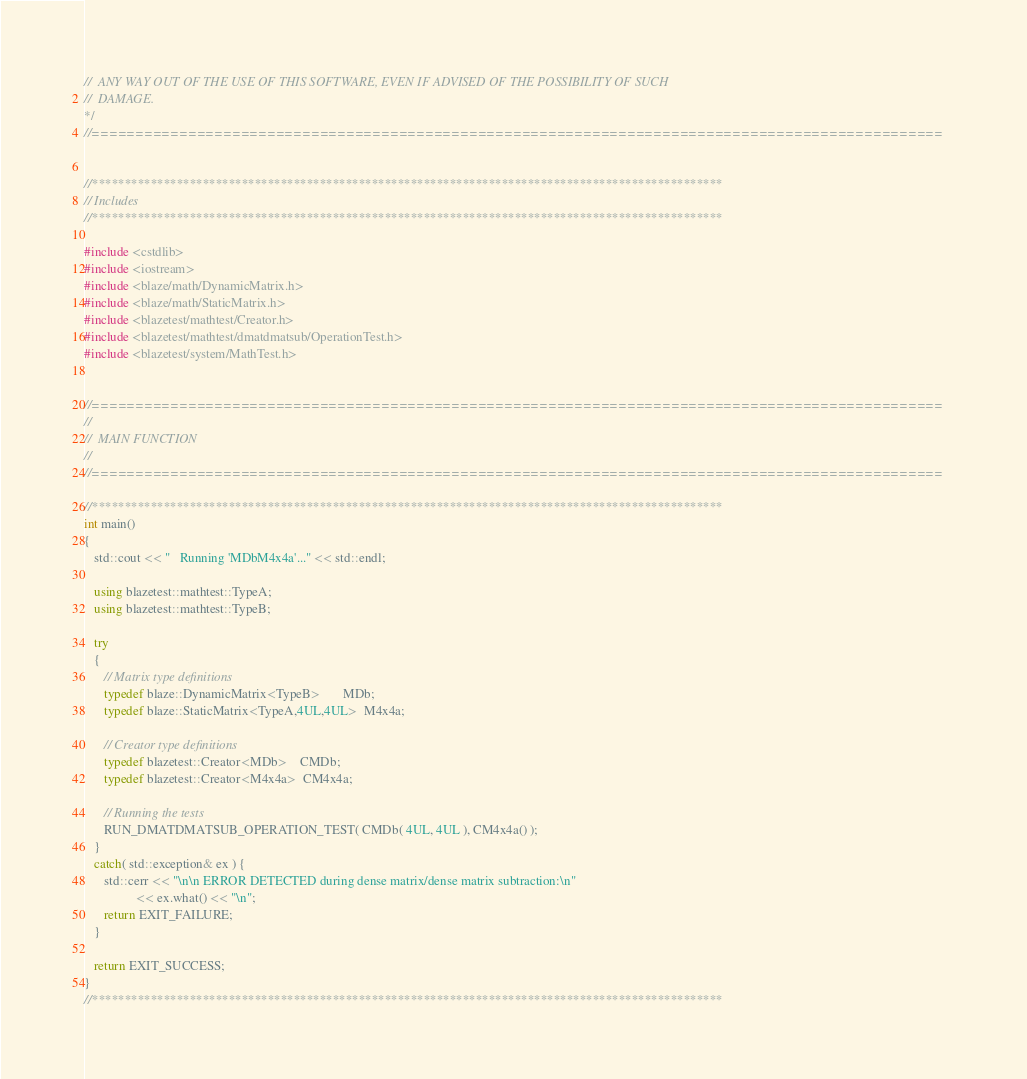<code> <loc_0><loc_0><loc_500><loc_500><_C++_>//  ANY WAY OUT OF THE USE OF THIS SOFTWARE, EVEN IF ADVISED OF THE POSSIBILITY OF SUCH
//  DAMAGE.
*/
//=================================================================================================


//*************************************************************************************************
// Includes
//*************************************************************************************************

#include <cstdlib>
#include <iostream>
#include <blaze/math/DynamicMatrix.h>
#include <blaze/math/StaticMatrix.h>
#include <blazetest/mathtest/Creator.h>
#include <blazetest/mathtest/dmatdmatsub/OperationTest.h>
#include <blazetest/system/MathTest.h>


//=================================================================================================
//
//  MAIN FUNCTION
//
//=================================================================================================

//*************************************************************************************************
int main()
{
   std::cout << "   Running 'MDbM4x4a'..." << std::endl;

   using blazetest::mathtest::TypeA;
   using blazetest::mathtest::TypeB;

   try
   {
      // Matrix type definitions
      typedef blaze::DynamicMatrix<TypeB>       MDb;
      typedef blaze::StaticMatrix<TypeA,4UL,4UL>  M4x4a;

      // Creator type definitions
      typedef blazetest::Creator<MDb>    CMDb;
      typedef blazetest::Creator<M4x4a>  CM4x4a;

      // Running the tests
      RUN_DMATDMATSUB_OPERATION_TEST( CMDb( 4UL, 4UL ), CM4x4a() );
   }
   catch( std::exception& ex ) {
      std::cerr << "\n\n ERROR DETECTED during dense matrix/dense matrix subtraction:\n"
                << ex.what() << "\n";
      return EXIT_FAILURE;
   }

   return EXIT_SUCCESS;
}
//*************************************************************************************************
</code> 